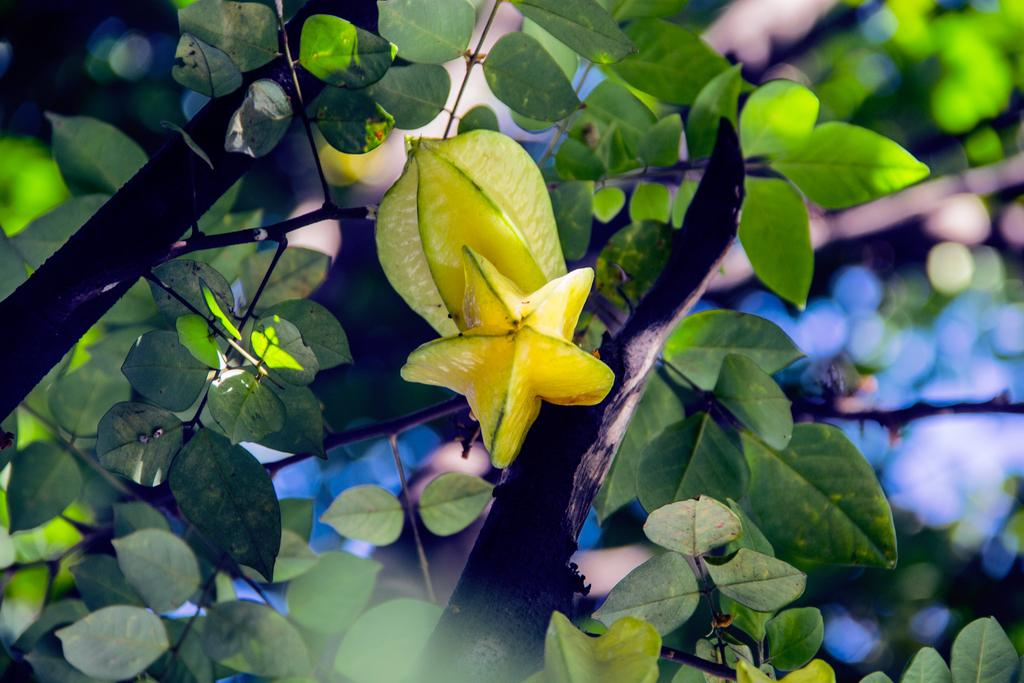What is the main subject of the image? The main subject of the image is a tree branch. What can be observed about the tree in the image? The bark of the tree is visible in the image. What type of vegetation is present on the branch? Leaves are present on the branch. Are there any flowers visible on the branch? Yes, there is a flower on the branch. What type of debt is the tree branch trying to pay off in the image? There is no indication of debt in the image, as it features a tree branch with bark, leaves, and a flower. Can you tell me how many carpenters are working on the tree branch in the image? There are no carpenters present in the image; it is a close-up of a tree branch with leaves and a flower. 